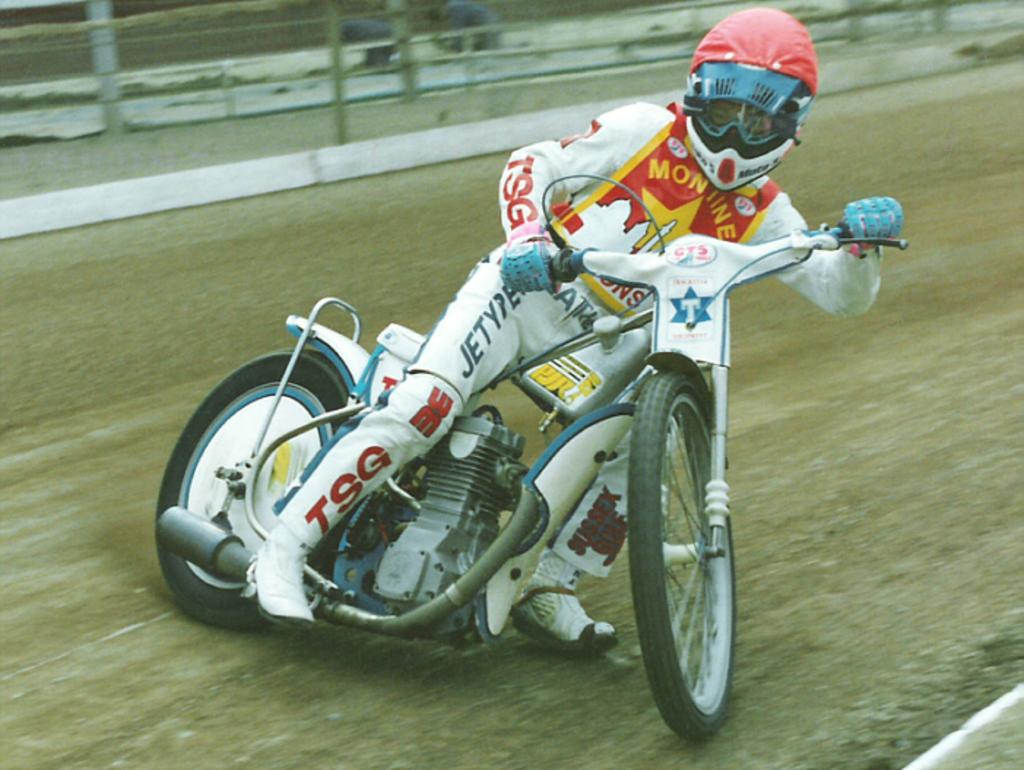What is the main subject of the image? The main subject of the image is a man. What is the man doing in the image? The man is riding a white bike in the image. What is the man wearing on his head? The man is wearing a red helmet in the image. What can be seen in the background of the image? There is fencing in the background of the image. What type of verse can be heard being recited by the man in the image? There is no indication in the image that the man is reciting any verse, so it cannot be determined from the picture. 